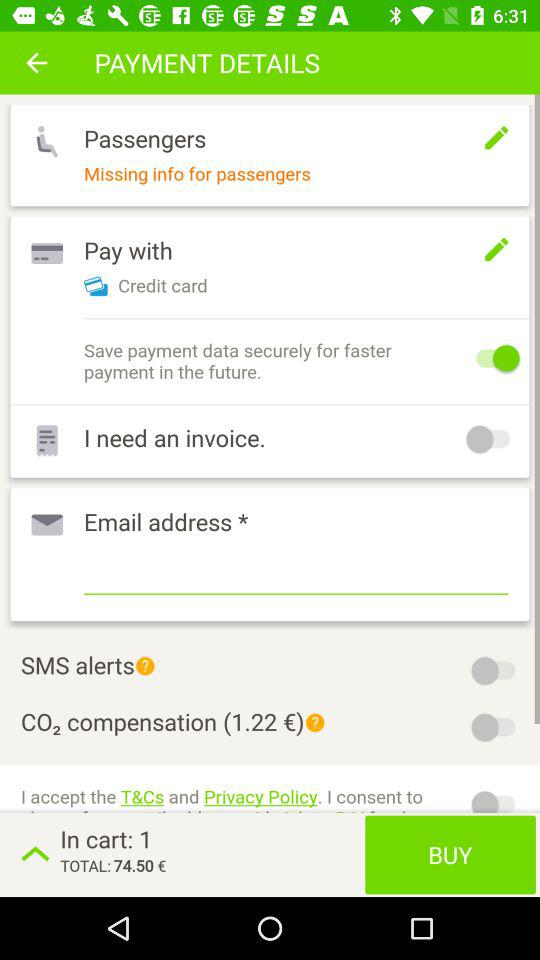Is "SMS alerts" enabled? "SMS alerts" is disabled. 